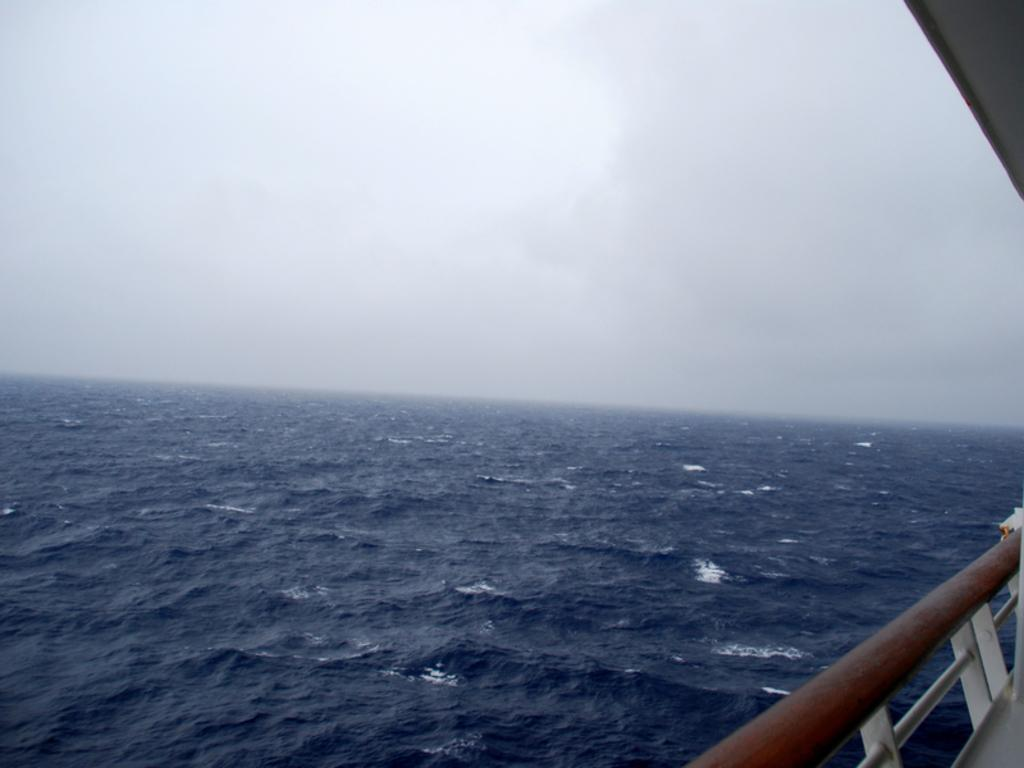What type of material is used to construct the fence on the right side of the image? The fence is made with metal. What can be seen in the background of the image? Water and the sky are visible in the background of the image. Can you describe the object in the top right corner of the image? Unfortunately, the facts provided do not give enough information to describe the object in the top right corner of the image. How many cherries are floating on the water in the image? There are no cherries visible in the image. What is the object in the top right corner of the image used for learning purposes? The facts provided do not give enough information to determine the purpose of the object in the top right corner of the image. 